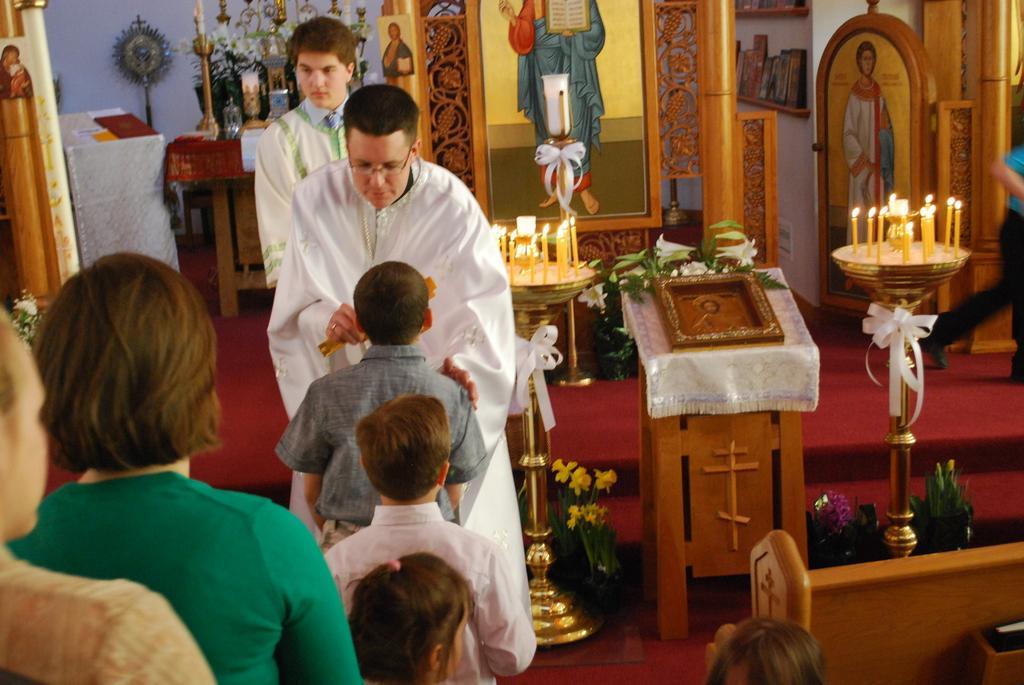How would you summarize this image in a sentence or two? In this picture we can see group of people, they are all in the church, in the background we can see few candle stands, candles, plants, flowers and few bottles on the table, and we can see books in the rack, in the background we can find few frames. 